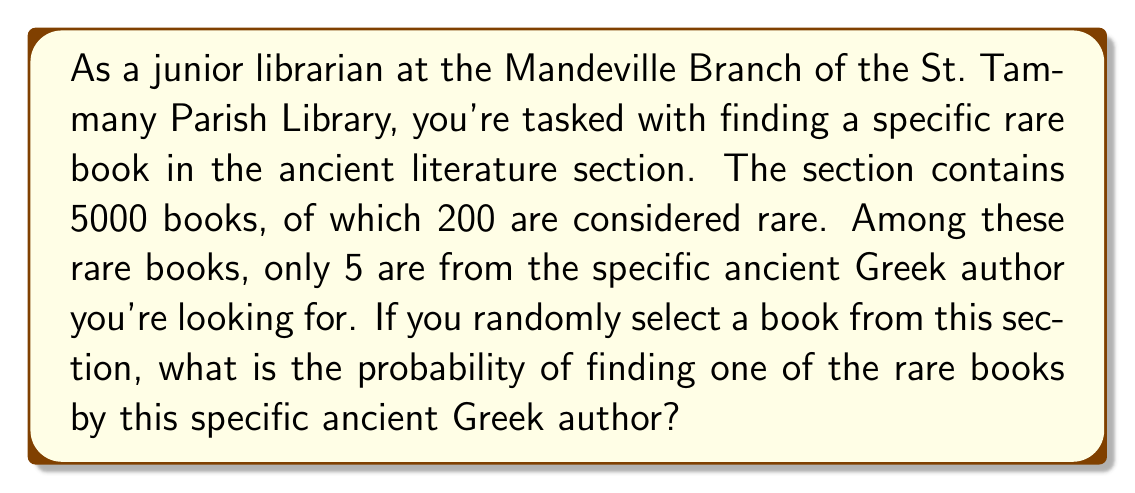Provide a solution to this math problem. Let's approach this step-by-step using probability theory:

1) First, we need to identify the total number of possible outcomes and the number of favorable outcomes:

   - Total number of books in the section: 5000
   - Number of rare books by the specific ancient Greek author: 5

2) The probability of an event is calculated by dividing the number of favorable outcomes by the total number of possible outcomes:

   $$P(\text{event}) = \frac{\text{number of favorable outcomes}}{\text{total number of possible outcomes}}$$

3) In this case:

   $$P(\text{finding a rare book by the specific author}) = \frac{5}{5000}$$

4) To simplify this fraction:

   $$\frac{5}{5000} = \frac{1}{1000} = 0.001$$

5) To express this as a percentage, we multiply by 100:

   $$0.001 \times 100 = 0.1\%$$

Therefore, the probability of randomly selecting one of the rare books by the specific ancient Greek author is 0.001 or 0.1%.
Answer: The probability is $\frac{1}{1000}$ or 0.001 or 0.1%. 